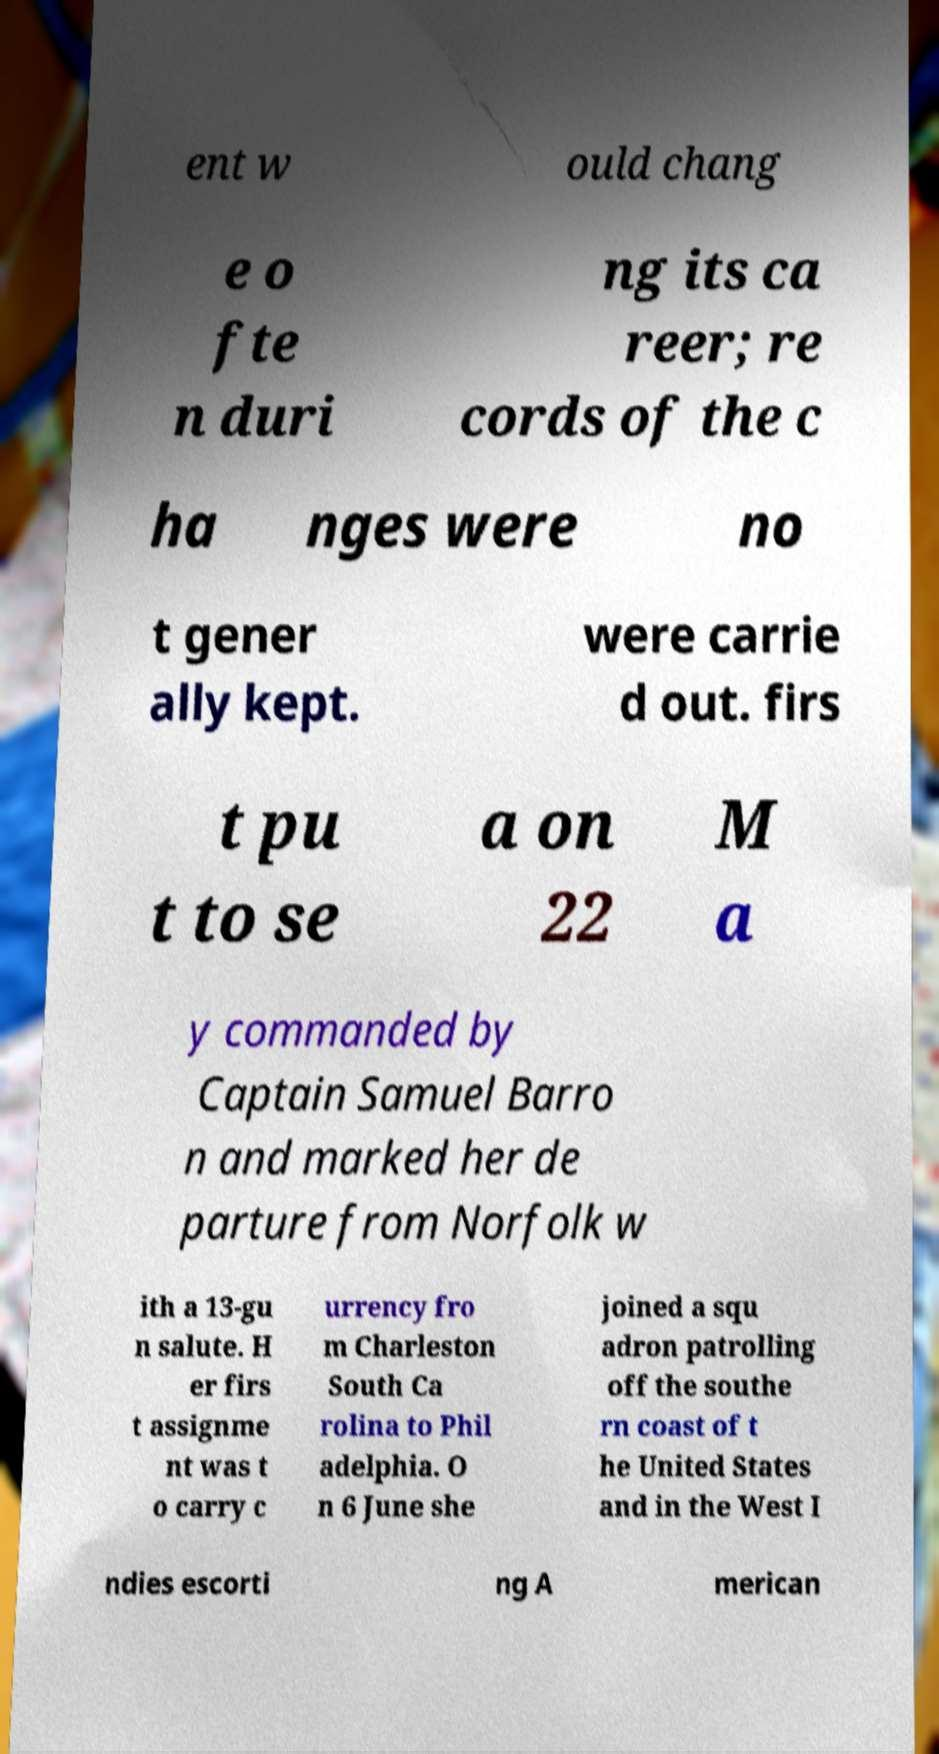Could you extract and type out the text from this image? ent w ould chang e o fte n duri ng its ca reer; re cords of the c ha nges were no t gener ally kept. were carrie d out. firs t pu t to se a on 22 M a y commanded by Captain Samuel Barro n and marked her de parture from Norfolk w ith a 13-gu n salute. H er firs t assignme nt was t o carry c urrency fro m Charleston South Ca rolina to Phil adelphia. O n 6 June she joined a squ adron patrolling off the southe rn coast of t he United States and in the West I ndies escorti ng A merican 